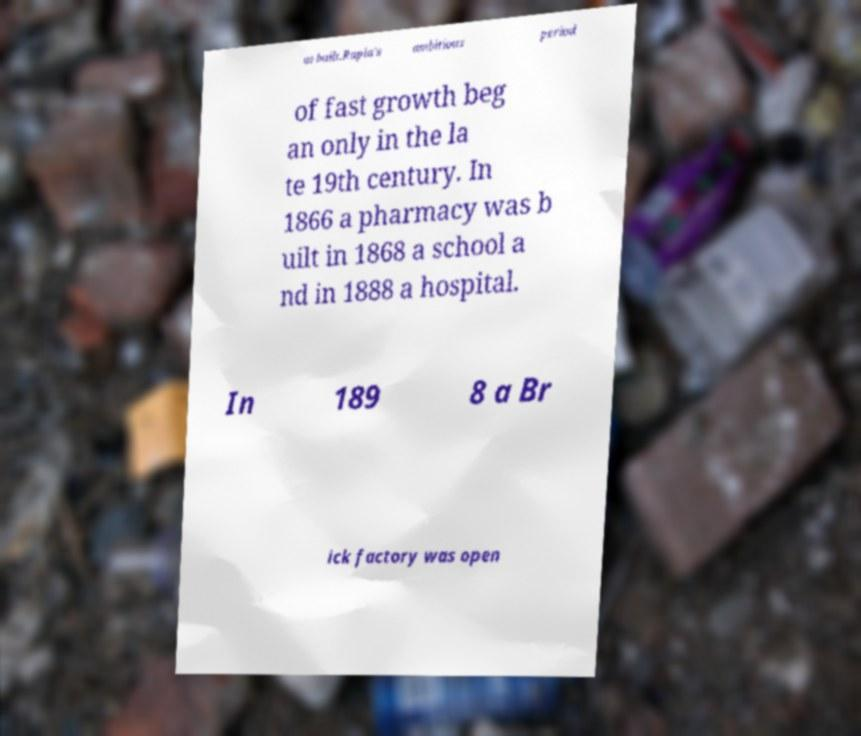Could you assist in decoding the text presented in this image and type it out clearly? as built.Rapla's ambitious period of fast growth beg an only in the la te 19th century. In 1866 a pharmacy was b uilt in 1868 a school a nd in 1888 a hospital. In 189 8 a Br ick factory was open 